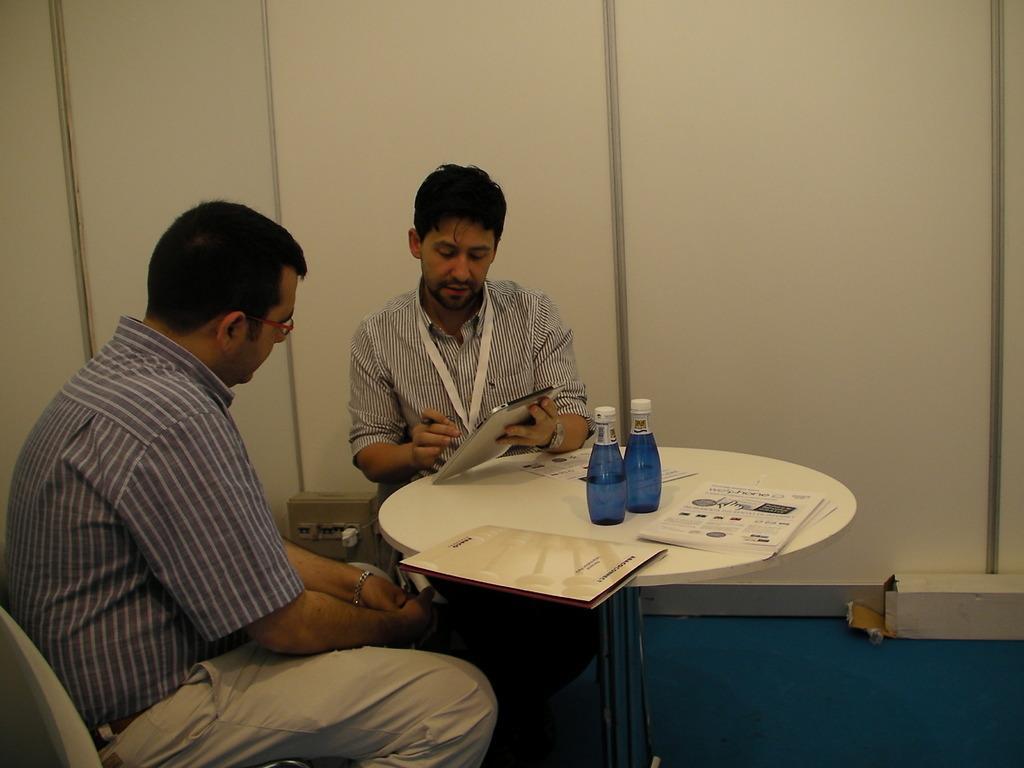Describe this image in one or two sentences. On the table we can see bottles, papers and a file. We can see this man holding a gadget in his hand and explaining something to this person. He wore spectacles. This is a floor. 